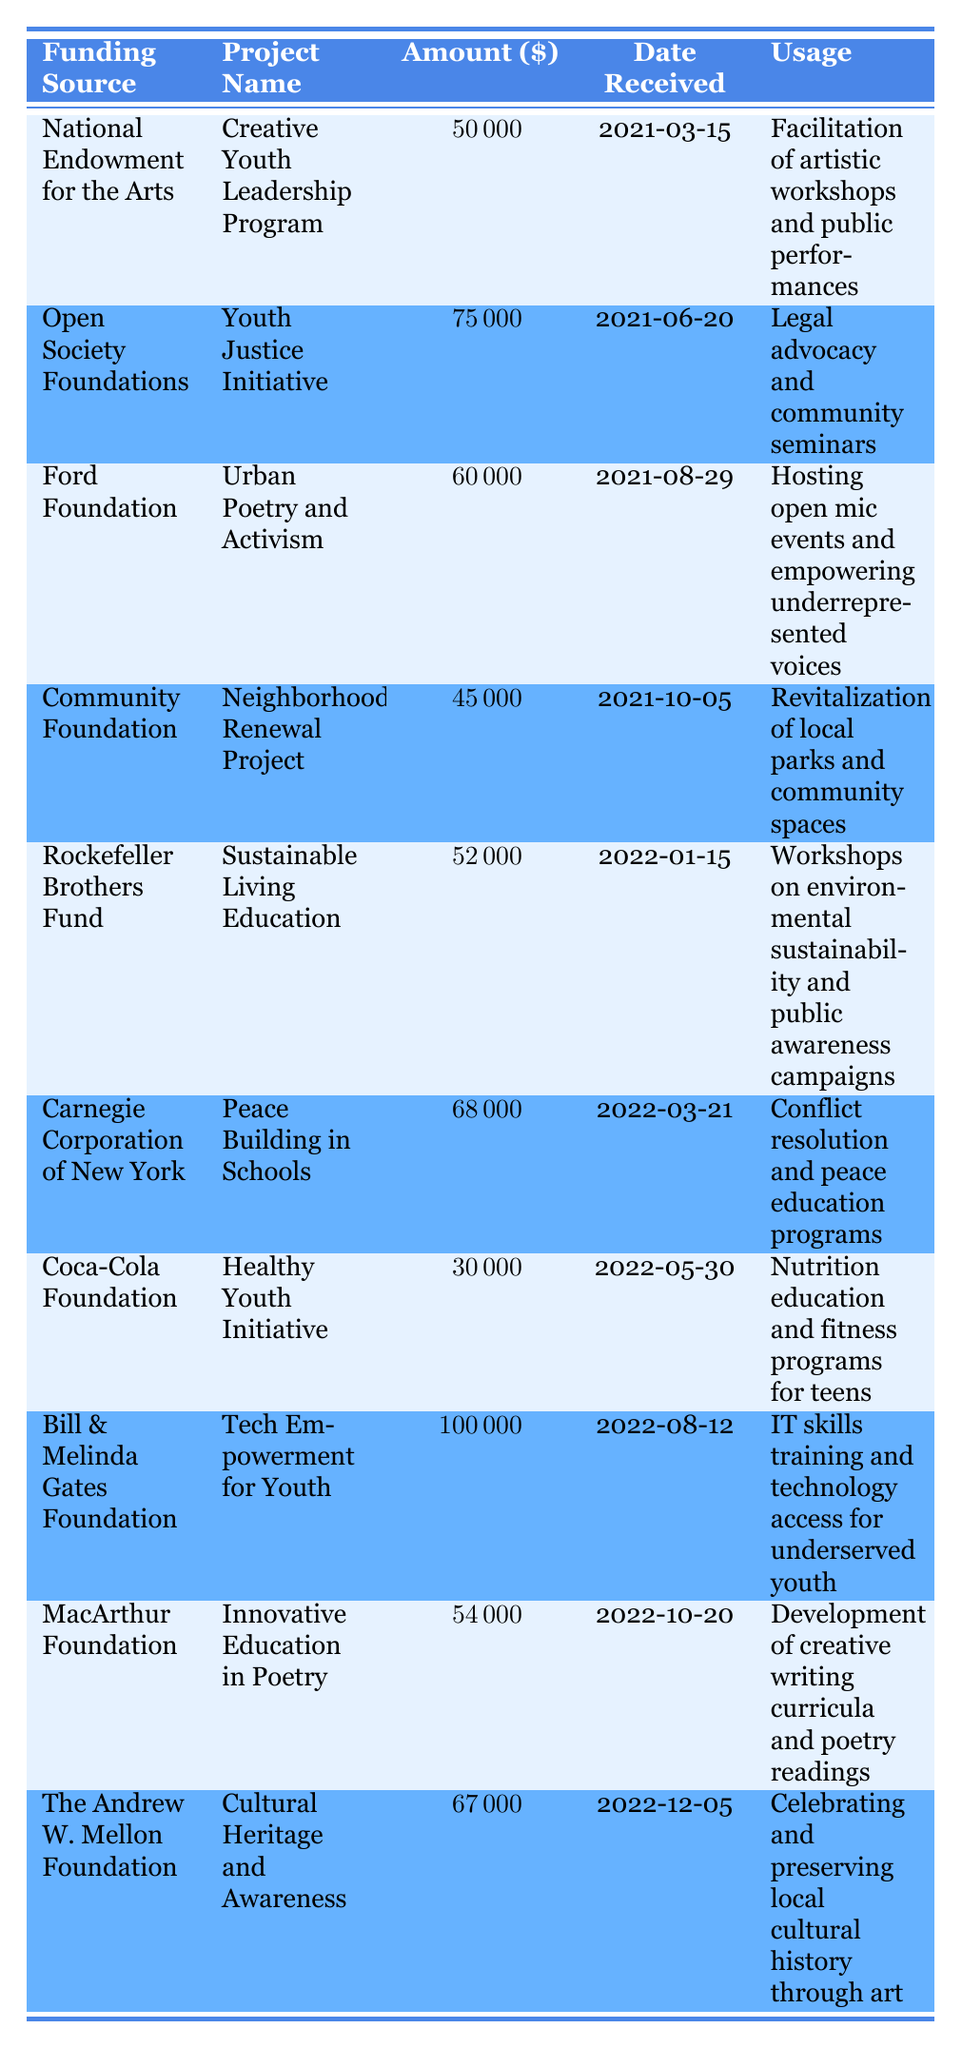What is the total amount received from all funding sources combined? To find the total, sum up all the amounts in the "Amount Received" column: 50000 + 75000 + 60000 + 45000 + 52000 + 68000 + 30000 + 100000 + 54000 + 67000 =  500000.
Answer: 500000 Which project received the highest amount in grants and donations? The project “Tech Empowerment for Youth” received the highest amount, which is 100000. Simply find the maximum in the "Amount Received" column.
Answer: Tech Empowerment for Youth Is the "Neighborhood Renewal Project" funded by more than one source? The "Neighborhood Renewal Project" is only funded by the Community Foundation as seen in the table. Therefore, it is not funded by more than one source.
Answer: No What was the average amount received per project? There are 10 projects in total. To find the average, sum all the amounts (50000 + 75000 + 60000 + 45000 + 52000 + 68000 + 30000 + 100000 + 54000 + 67000 = 500000) and divide by 10, which gives 50000.
Answer: 50000 Did the "Creative Youth Leadership Program" receive more funding than the "Healthy Youth Initiative"? The "Creative Youth Leadership Program" received 50000, while the "Healthy Youth Initiative" received 30000. Since 50000 is greater than 30000, the statement is true.
Answer: Yes How much funding did the Ford Foundation provide, and what was the date it was received? The Ford Foundation provided 60000 for the "Urban Poetry and Activism" project, which was received on 2021-08-29.
Answer: 60000 on 2021-08-29 What is the total amount received from foundations (not including Community Foundation or Coca-Cola Foundation)? The applicable foundations are National Endowment for the Arts, Open Society Foundations, Ford Foundation, Rockefeller Brothers Fund, Carnegie Corporation of New York, Bill & Melinda Gates Foundation, MacArthur Foundation, and The Andrew W. Mellon Foundation. Their funding totals: 50000 + 75000 + 60000 + 52000 + 68000 + 100000 + 54000 + 67000 =  500000. The Community Foundation and Coca-Cola Foundation are excluded.
Answer: 470000 Which two projects received funding in 2022? The projects "Sustainable Living Education" and "Peace Building in Schools" received funding in the year 2022. You can find these projects by looking at the "Date Received" column for dates within that year.
Answer: 2 projects What percentage of the total funding does the "Youth Justice Initiative" represent? The "Youth Justice Initiative" received 75000. To find the percentage: (75000 / 500000) * 100 = 15%.
Answer: 15% 